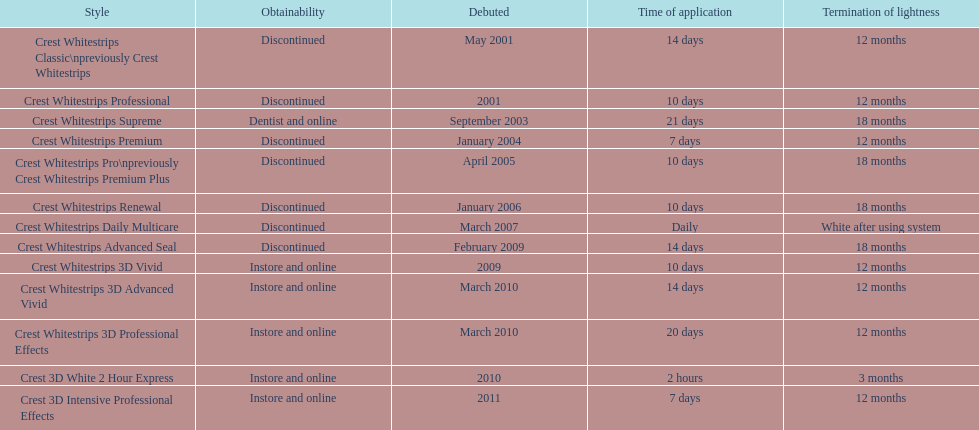What is the number of products that were introduced in 2010? 3. 